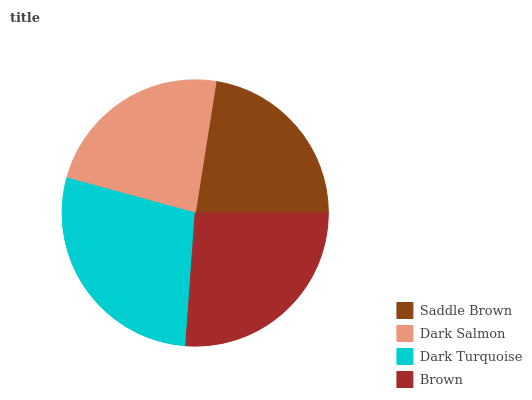Is Saddle Brown the minimum?
Answer yes or no. Yes. Is Dark Turquoise the maximum?
Answer yes or no. Yes. Is Dark Salmon the minimum?
Answer yes or no. No. Is Dark Salmon the maximum?
Answer yes or no. No. Is Dark Salmon greater than Saddle Brown?
Answer yes or no. Yes. Is Saddle Brown less than Dark Salmon?
Answer yes or no. Yes. Is Saddle Brown greater than Dark Salmon?
Answer yes or no. No. Is Dark Salmon less than Saddle Brown?
Answer yes or no. No. Is Brown the high median?
Answer yes or no. Yes. Is Dark Salmon the low median?
Answer yes or no. Yes. Is Saddle Brown the high median?
Answer yes or no. No. Is Saddle Brown the low median?
Answer yes or no. No. 